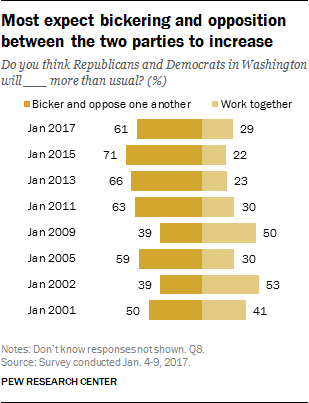Identify some key points in this picture. The difference between the highest and lowest yellow bar is 31. There are two colors in the bars. 